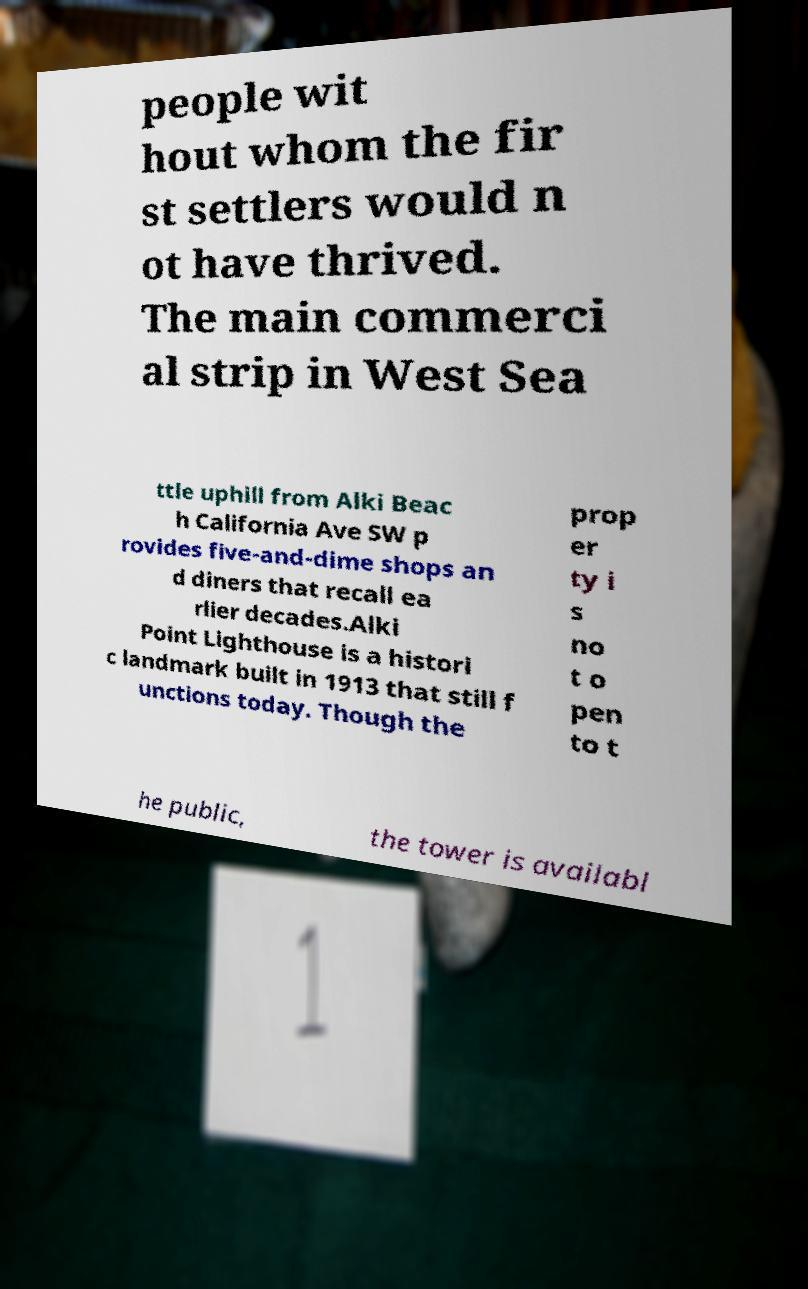Can you read and provide the text displayed in the image?This photo seems to have some interesting text. Can you extract and type it out for me? people wit hout whom the fir st settlers would n ot have thrived. The main commerci al strip in West Sea ttle uphill from Alki Beac h California Ave SW p rovides five-and-dime shops an d diners that recall ea rlier decades.Alki Point Lighthouse is a histori c landmark built in 1913 that still f unctions today. Though the prop er ty i s no t o pen to t he public, the tower is availabl 